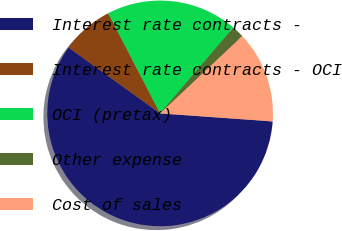Convert chart. <chart><loc_0><loc_0><loc_500><loc_500><pie_chart><fcel>Interest rate contracts -<fcel>Interest rate contracts - OCI<fcel>OCI (pretax)<fcel>Other expense<fcel>Cost of sales<nl><fcel>58.8%<fcel>7.45%<fcel>18.86%<fcel>1.74%<fcel>13.15%<nl></chart> 